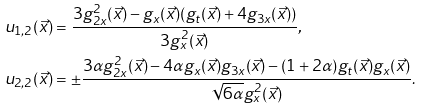<formula> <loc_0><loc_0><loc_500><loc_500>u _ { 1 , 2 } ( \vec { x } ) & = \frac { 3 g _ { 2 x } ^ { 2 } ( \vec { x } ) - g _ { x } ( \vec { x } ) ( g _ { t } ( \vec { x } ) + 4 g _ { 3 x } ( \vec { x } ) ) } { 3 g _ { x } ^ { 2 } ( \vec { x } ) } , \\ u _ { 2 , 2 } ( \vec { x } ) & = \pm \frac { 3 \alpha g _ { 2 x } ^ { 2 } ( \vec { x } ) - 4 \alpha g _ { x } ( \vec { x } ) g _ { 3 x } ( \vec { x } ) - ( 1 + 2 \alpha ) g _ { t } ( \vec { x } ) g _ { x } ( \vec { x } ) } { \sqrt { 6 \alpha } g _ { x } ^ { 2 } ( \vec { x } ) } .</formula> 